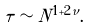Convert formula to latex. <formula><loc_0><loc_0><loc_500><loc_500>\tau \sim N ^ { 1 + 2 \nu } .</formula> 